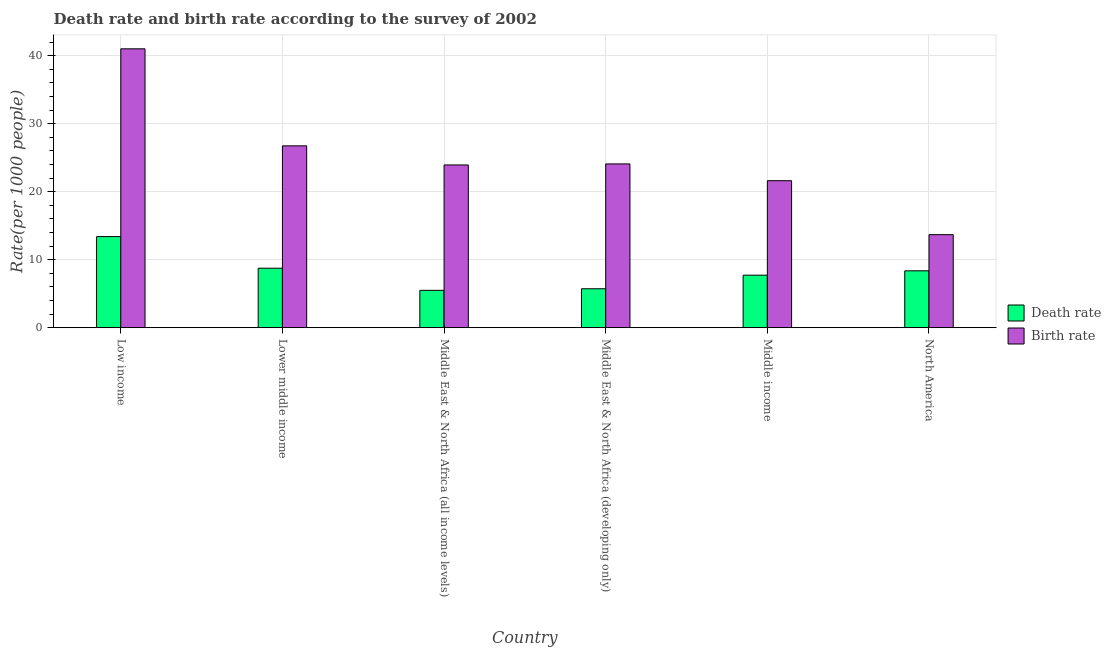Are the number of bars on each tick of the X-axis equal?
Make the answer very short. Yes. In how many cases, is the number of bars for a given country not equal to the number of legend labels?
Offer a terse response. 0. What is the death rate in Lower middle income?
Offer a very short reply. 8.74. Across all countries, what is the maximum death rate?
Keep it short and to the point. 13.39. Across all countries, what is the minimum death rate?
Provide a succinct answer. 5.49. In which country was the death rate minimum?
Provide a short and direct response. Middle East & North Africa (all income levels). What is the total birth rate in the graph?
Ensure brevity in your answer.  151.04. What is the difference between the death rate in Middle East & North Africa (all income levels) and that in Middle income?
Your response must be concise. -2.23. What is the difference between the birth rate in Low income and the death rate in Middle income?
Make the answer very short. 33.29. What is the average birth rate per country?
Your answer should be compact. 25.17. What is the difference between the birth rate and death rate in Middle income?
Your response must be concise. 13.89. In how many countries, is the death rate greater than 20 ?
Keep it short and to the point. 0. What is the ratio of the death rate in Low income to that in Middle income?
Your answer should be compact. 1.74. Is the difference between the birth rate in Lower middle income and North America greater than the difference between the death rate in Lower middle income and North America?
Offer a very short reply. Yes. What is the difference between the highest and the second highest death rate?
Provide a short and direct response. 4.65. What is the difference between the highest and the lowest birth rate?
Your response must be concise. 27.33. In how many countries, is the birth rate greater than the average birth rate taken over all countries?
Provide a short and direct response. 2. Is the sum of the birth rate in Lower middle income and Middle East & North Africa (all income levels) greater than the maximum death rate across all countries?
Offer a terse response. Yes. What does the 1st bar from the left in Middle East & North Africa (all income levels) represents?
Your answer should be very brief. Death rate. What does the 1st bar from the right in Middle income represents?
Provide a short and direct response. Birth rate. Are all the bars in the graph horizontal?
Provide a succinct answer. No. What is the difference between two consecutive major ticks on the Y-axis?
Keep it short and to the point. 10. Are the values on the major ticks of Y-axis written in scientific E-notation?
Make the answer very short. No. How many legend labels are there?
Provide a short and direct response. 2. What is the title of the graph?
Keep it short and to the point. Death rate and birth rate according to the survey of 2002. What is the label or title of the X-axis?
Ensure brevity in your answer.  Country. What is the label or title of the Y-axis?
Offer a terse response. Rate(per 1000 people). What is the Rate(per 1000 people) of Death rate in Low income?
Keep it short and to the point. 13.39. What is the Rate(per 1000 people) of Birth rate in Low income?
Keep it short and to the point. 41.01. What is the Rate(per 1000 people) of Death rate in Lower middle income?
Your answer should be very brief. 8.74. What is the Rate(per 1000 people) in Birth rate in Lower middle income?
Give a very brief answer. 26.74. What is the Rate(per 1000 people) of Death rate in Middle East & North Africa (all income levels)?
Your answer should be very brief. 5.49. What is the Rate(per 1000 people) of Birth rate in Middle East & North Africa (all income levels)?
Keep it short and to the point. 23.93. What is the Rate(per 1000 people) in Death rate in Middle East & North Africa (developing only)?
Provide a short and direct response. 5.72. What is the Rate(per 1000 people) in Birth rate in Middle East & North Africa (developing only)?
Ensure brevity in your answer.  24.08. What is the Rate(per 1000 people) of Death rate in Middle income?
Provide a short and direct response. 7.72. What is the Rate(per 1000 people) of Birth rate in Middle income?
Make the answer very short. 21.61. What is the Rate(per 1000 people) of Death rate in North America?
Give a very brief answer. 8.36. What is the Rate(per 1000 people) in Birth rate in North America?
Your answer should be compact. 13.68. Across all countries, what is the maximum Rate(per 1000 people) of Death rate?
Make the answer very short. 13.39. Across all countries, what is the maximum Rate(per 1000 people) in Birth rate?
Offer a very short reply. 41.01. Across all countries, what is the minimum Rate(per 1000 people) in Death rate?
Your answer should be compact. 5.49. Across all countries, what is the minimum Rate(per 1000 people) of Birth rate?
Provide a short and direct response. 13.68. What is the total Rate(per 1000 people) of Death rate in the graph?
Offer a terse response. 49.43. What is the total Rate(per 1000 people) in Birth rate in the graph?
Your response must be concise. 151.04. What is the difference between the Rate(per 1000 people) in Death rate in Low income and that in Lower middle income?
Offer a terse response. 4.65. What is the difference between the Rate(per 1000 people) of Birth rate in Low income and that in Lower middle income?
Make the answer very short. 14.27. What is the difference between the Rate(per 1000 people) in Death rate in Low income and that in Middle East & North Africa (all income levels)?
Provide a short and direct response. 7.9. What is the difference between the Rate(per 1000 people) in Birth rate in Low income and that in Middle East & North Africa (all income levels)?
Keep it short and to the point. 17.08. What is the difference between the Rate(per 1000 people) in Death rate in Low income and that in Middle East & North Africa (developing only)?
Keep it short and to the point. 7.67. What is the difference between the Rate(per 1000 people) of Birth rate in Low income and that in Middle East & North Africa (developing only)?
Offer a very short reply. 16.93. What is the difference between the Rate(per 1000 people) in Death rate in Low income and that in Middle income?
Make the answer very short. 5.67. What is the difference between the Rate(per 1000 people) of Birth rate in Low income and that in Middle income?
Provide a short and direct response. 19.4. What is the difference between the Rate(per 1000 people) in Death rate in Low income and that in North America?
Your answer should be compact. 5.03. What is the difference between the Rate(per 1000 people) of Birth rate in Low income and that in North America?
Offer a terse response. 27.33. What is the difference between the Rate(per 1000 people) in Death rate in Lower middle income and that in Middle East & North Africa (all income levels)?
Keep it short and to the point. 3.25. What is the difference between the Rate(per 1000 people) in Birth rate in Lower middle income and that in Middle East & North Africa (all income levels)?
Make the answer very short. 2.81. What is the difference between the Rate(per 1000 people) in Death rate in Lower middle income and that in Middle East & North Africa (developing only)?
Your response must be concise. 3.02. What is the difference between the Rate(per 1000 people) in Birth rate in Lower middle income and that in Middle East & North Africa (developing only)?
Ensure brevity in your answer.  2.66. What is the difference between the Rate(per 1000 people) of Death rate in Lower middle income and that in Middle income?
Ensure brevity in your answer.  1.02. What is the difference between the Rate(per 1000 people) in Birth rate in Lower middle income and that in Middle income?
Make the answer very short. 5.13. What is the difference between the Rate(per 1000 people) in Death rate in Lower middle income and that in North America?
Make the answer very short. 0.38. What is the difference between the Rate(per 1000 people) in Birth rate in Lower middle income and that in North America?
Give a very brief answer. 13.06. What is the difference between the Rate(per 1000 people) in Death rate in Middle East & North Africa (all income levels) and that in Middle East & North Africa (developing only)?
Your answer should be compact. -0.23. What is the difference between the Rate(per 1000 people) in Birth rate in Middle East & North Africa (all income levels) and that in Middle East & North Africa (developing only)?
Give a very brief answer. -0.15. What is the difference between the Rate(per 1000 people) in Death rate in Middle East & North Africa (all income levels) and that in Middle income?
Give a very brief answer. -2.23. What is the difference between the Rate(per 1000 people) in Birth rate in Middle East & North Africa (all income levels) and that in Middle income?
Give a very brief answer. 2.32. What is the difference between the Rate(per 1000 people) of Death rate in Middle East & North Africa (all income levels) and that in North America?
Offer a terse response. -2.87. What is the difference between the Rate(per 1000 people) in Birth rate in Middle East & North Africa (all income levels) and that in North America?
Your response must be concise. 10.25. What is the difference between the Rate(per 1000 people) in Death rate in Middle East & North Africa (developing only) and that in Middle income?
Make the answer very short. -2. What is the difference between the Rate(per 1000 people) of Birth rate in Middle East & North Africa (developing only) and that in Middle income?
Give a very brief answer. 2.47. What is the difference between the Rate(per 1000 people) of Death rate in Middle East & North Africa (developing only) and that in North America?
Give a very brief answer. -2.64. What is the difference between the Rate(per 1000 people) in Birth rate in Middle East & North Africa (developing only) and that in North America?
Keep it short and to the point. 10.41. What is the difference between the Rate(per 1000 people) of Death rate in Middle income and that in North America?
Make the answer very short. -0.64. What is the difference between the Rate(per 1000 people) of Birth rate in Middle income and that in North America?
Your answer should be compact. 7.94. What is the difference between the Rate(per 1000 people) of Death rate in Low income and the Rate(per 1000 people) of Birth rate in Lower middle income?
Your answer should be very brief. -13.35. What is the difference between the Rate(per 1000 people) of Death rate in Low income and the Rate(per 1000 people) of Birth rate in Middle East & North Africa (all income levels)?
Your answer should be very brief. -10.54. What is the difference between the Rate(per 1000 people) of Death rate in Low income and the Rate(per 1000 people) of Birth rate in Middle East & North Africa (developing only)?
Offer a terse response. -10.69. What is the difference between the Rate(per 1000 people) in Death rate in Low income and the Rate(per 1000 people) in Birth rate in Middle income?
Your response must be concise. -8.22. What is the difference between the Rate(per 1000 people) of Death rate in Low income and the Rate(per 1000 people) of Birth rate in North America?
Give a very brief answer. -0.28. What is the difference between the Rate(per 1000 people) in Death rate in Lower middle income and the Rate(per 1000 people) in Birth rate in Middle East & North Africa (all income levels)?
Ensure brevity in your answer.  -15.18. What is the difference between the Rate(per 1000 people) in Death rate in Lower middle income and the Rate(per 1000 people) in Birth rate in Middle East & North Africa (developing only)?
Offer a terse response. -15.34. What is the difference between the Rate(per 1000 people) of Death rate in Lower middle income and the Rate(per 1000 people) of Birth rate in Middle income?
Keep it short and to the point. -12.87. What is the difference between the Rate(per 1000 people) in Death rate in Lower middle income and the Rate(per 1000 people) in Birth rate in North America?
Keep it short and to the point. -4.93. What is the difference between the Rate(per 1000 people) in Death rate in Middle East & North Africa (all income levels) and the Rate(per 1000 people) in Birth rate in Middle East & North Africa (developing only)?
Your answer should be compact. -18.59. What is the difference between the Rate(per 1000 people) of Death rate in Middle East & North Africa (all income levels) and the Rate(per 1000 people) of Birth rate in Middle income?
Your answer should be very brief. -16.12. What is the difference between the Rate(per 1000 people) in Death rate in Middle East & North Africa (all income levels) and the Rate(per 1000 people) in Birth rate in North America?
Keep it short and to the point. -8.19. What is the difference between the Rate(per 1000 people) of Death rate in Middle East & North Africa (developing only) and the Rate(per 1000 people) of Birth rate in Middle income?
Give a very brief answer. -15.89. What is the difference between the Rate(per 1000 people) in Death rate in Middle East & North Africa (developing only) and the Rate(per 1000 people) in Birth rate in North America?
Give a very brief answer. -7.95. What is the difference between the Rate(per 1000 people) of Death rate in Middle income and the Rate(per 1000 people) of Birth rate in North America?
Offer a terse response. -5.96. What is the average Rate(per 1000 people) of Death rate per country?
Your response must be concise. 8.24. What is the average Rate(per 1000 people) of Birth rate per country?
Provide a succinct answer. 25.17. What is the difference between the Rate(per 1000 people) of Death rate and Rate(per 1000 people) of Birth rate in Low income?
Provide a short and direct response. -27.61. What is the difference between the Rate(per 1000 people) in Death rate and Rate(per 1000 people) in Birth rate in Lower middle income?
Your response must be concise. -17.99. What is the difference between the Rate(per 1000 people) in Death rate and Rate(per 1000 people) in Birth rate in Middle East & North Africa (all income levels)?
Your response must be concise. -18.44. What is the difference between the Rate(per 1000 people) of Death rate and Rate(per 1000 people) of Birth rate in Middle East & North Africa (developing only)?
Your answer should be very brief. -18.36. What is the difference between the Rate(per 1000 people) of Death rate and Rate(per 1000 people) of Birth rate in Middle income?
Offer a terse response. -13.89. What is the difference between the Rate(per 1000 people) in Death rate and Rate(per 1000 people) in Birth rate in North America?
Provide a short and direct response. -5.31. What is the ratio of the Rate(per 1000 people) in Death rate in Low income to that in Lower middle income?
Provide a succinct answer. 1.53. What is the ratio of the Rate(per 1000 people) of Birth rate in Low income to that in Lower middle income?
Offer a terse response. 1.53. What is the ratio of the Rate(per 1000 people) in Death rate in Low income to that in Middle East & North Africa (all income levels)?
Your answer should be very brief. 2.44. What is the ratio of the Rate(per 1000 people) in Birth rate in Low income to that in Middle East & North Africa (all income levels)?
Ensure brevity in your answer.  1.71. What is the ratio of the Rate(per 1000 people) in Death rate in Low income to that in Middle East & North Africa (developing only)?
Provide a short and direct response. 2.34. What is the ratio of the Rate(per 1000 people) of Birth rate in Low income to that in Middle East & North Africa (developing only)?
Provide a succinct answer. 1.7. What is the ratio of the Rate(per 1000 people) of Death rate in Low income to that in Middle income?
Your answer should be very brief. 1.74. What is the ratio of the Rate(per 1000 people) in Birth rate in Low income to that in Middle income?
Offer a terse response. 1.9. What is the ratio of the Rate(per 1000 people) in Death rate in Low income to that in North America?
Provide a short and direct response. 1.6. What is the ratio of the Rate(per 1000 people) in Birth rate in Low income to that in North America?
Your response must be concise. 3. What is the ratio of the Rate(per 1000 people) of Death rate in Lower middle income to that in Middle East & North Africa (all income levels)?
Your response must be concise. 1.59. What is the ratio of the Rate(per 1000 people) in Birth rate in Lower middle income to that in Middle East & North Africa (all income levels)?
Ensure brevity in your answer.  1.12. What is the ratio of the Rate(per 1000 people) in Death rate in Lower middle income to that in Middle East & North Africa (developing only)?
Your response must be concise. 1.53. What is the ratio of the Rate(per 1000 people) of Birth rate in Lower middle income to that in Middle East & North Africa (developing only)?
Your response must be concise. 1.11. What is the ratio of the Rate(per 1000 people) of Death rate in Lower middle income to that in Middle income?
Your answer should be compact. 1.13. What is the ratio of the Rate(per 1000 people) in Birth rate in Lower middle income to that in Middle income?
Keep it short and to the point. 1.24. What is the ratio of the Rate(per 1000 people) in Death rate in Lower middle income to that in North America?
Provide a short and direct response. 1.05. What is the ratio of the Rate(per 1000 people) in Birth rate in Lower middle income to that in North America?
Your answer should be compact. 1.96. What is the ratio of the Rate(per 1000 people) of Death rate in Middle East & North Africa (all income levels) to that in Middle East & North Africa (developing only)?
Make the answer very short. 0.96. What is the ratio of the Rate(per 1000 people) in Death rate in Middle East & North Africa (all income levels) to that in Middle income?
Offer a very short reply. 0.71. What is the ratio of the Rate(per 1000 people) of Birth rate in Middle East & North Africa (all income levels) to that in Middle income?
Offer a very short reply. 1.11. What is the ratio of the Rate(per 1000 people) of Death rate in Middle East & North Africa (all income levels) to that in North America?
Your answer should be very brief. 0.66. What is the ratio of the Rate(per 1000 people) of Birth rate in Middle East & North Africa (all income levels) to that in North America?
Your answer should be very brief. 1.75. What is the ratio of the Rate(per 1000 people) in Death rate in Middle East & North Africa (developing only) to that in Middle income?
Provide a short and direct response. 0.74. What is the ratio of the Rate(per 1000 people) of Birth rate in Middle East & North Africa (developing only) to that in Middle income?
Provide a succinct answer. 1.11. What is the ratio of the Rate(per 1000 people) of Death rate in Middle East & North Africa (developing only) to that in North America?
Keep it short and to the point. 0.68. What is the ratio of the Rate(per 1000 people) of Birth rate in Middle East & North Africa (developing only) to that in North America?
Give a very brief answer. 1.76. What is the ratio of the Rate(per 1000 people) in Death rate in Middle income to that in North America?
Ensure brevity in your answer.  0.92. What is the ratio of the Rate(per 1000 people) of Birth rate in Middle income to that in North America?
Keep it short and to the point. 1.58. What is the difference between the highest and the second highest Rate(per 1000 people) of Death rate?
Your response must be concise. 4.65. What is the difference between the highest and the second highest Rate(per 1000 people) of Birth rate?
Give a very brief answer. 14.27. What is the difference between the highest and the lowest Rate(per 1000 people) of Death rate?
Give a very brief answer. 7.9. What is the difference between the highest and the lowest Rate(per 1000 people) of Birth rate?
Give a very brief answer. 27.33. 